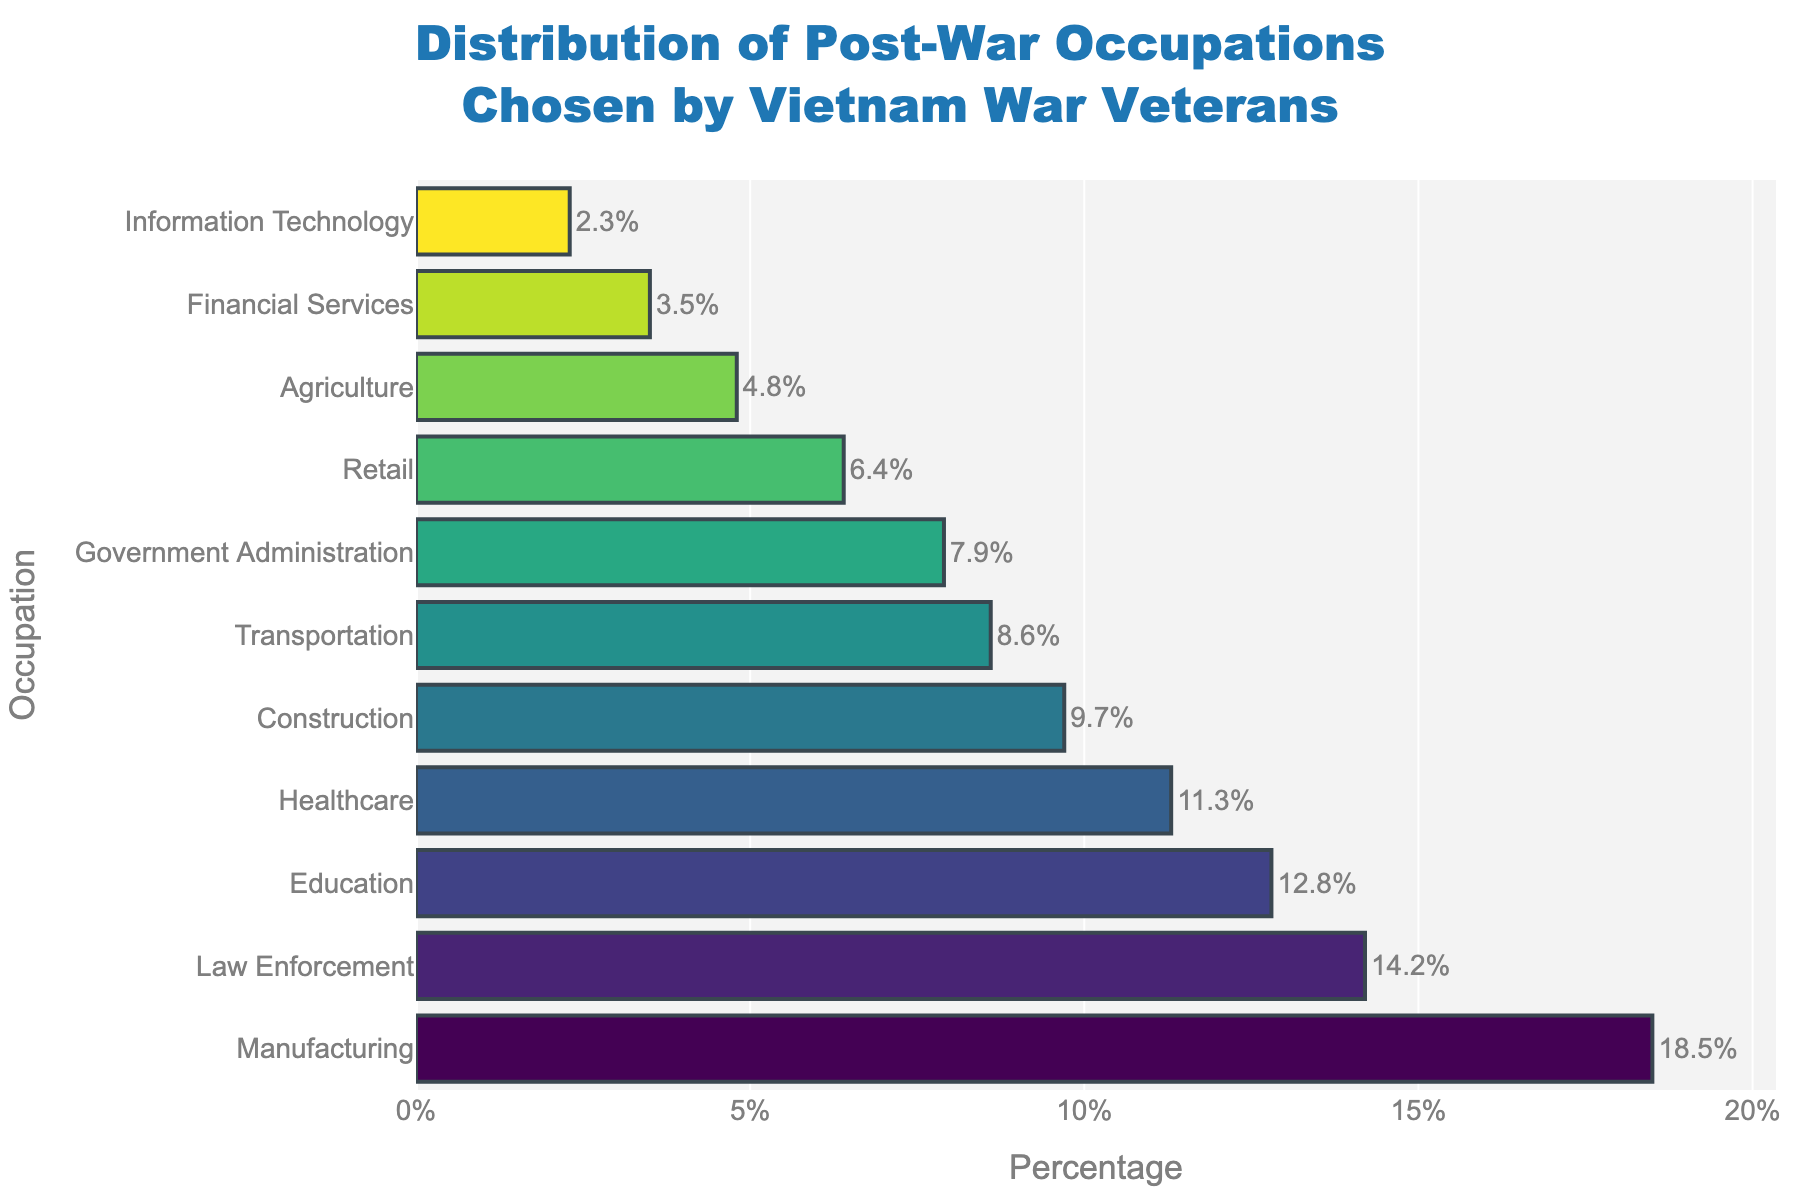What's the most common post-war occupation chosen by Vietnam War veterans? Look for the occupation with the highest percentage on the bar chart, which is Manufacturing with 18.5%.
Answer: Manufacturing Which post-war occupation has the lowest percentage? Identify the occupation with the shortest bar, which corresponds to Information Technology with 2.3%.
Answer: Information Technology What is the difference in percentage between the top two post-war occupations? Subtract the second highest percentage (Law Enforcement, 14.2%) from the highest percentage (Manufacturing, 18.5%). 18.5 - 14.2 = 4.3%.
Answer: 4.3% How much higher is the proportion of veterans in Manufacturing compared to those in Healthcare? Subtract the percentage for Healthcare (11.3%) from that of Manufacturing (18.5%). 18.5 - 11.3 = 7.2%.
Answer: 7.2% What is the combined percentage of veterans in Education, Healthcare, and Construction? Sum the three percentages: Education (12.8%), Healthcare (11.3%), and Construction (9.7%). 12.8 + 11.3 + 9.7 = 33.8%.
Answer: 33.8% Are there more veterans in Transportation or in Government Administration? Compare the percentages: Transportation has 8.6% while Government Administration has 7.9%. 8.6 > 7.9.
Answer: Transportation Which occupation has a percentage closest to 10%? Find the occupation whose percentage is nearest to 10%. Construction at 9.7% is the closest.
Answer: Construction What percentage of veterans chose Financial Services, and how does it compare to Retail? Financial Services has 3.5% while Retail has 6.4%. Since 3.5 < 6.4, Retail is more chosen.
Answer: Financial Services: 3.5%, Less than Retail What is the average percentage of veterans in the three least chosen occupations? Calculate the average of the percentages for the three occupations with the smallest values: Information Technology (2.3%), Financial Services (3.5%), and Agriculture (4.8%). (2.3 + 3.5 + 4.8) / 3 = 3.53%.
Answer: 3.53% What are the total percentages of veterans in Manufacturing, Law Enforcement, and Education combined? Sum the percentages for Manufacturing (18.5%), Law Enforcement (14.2%), and Education (12.8%). 18.5 + 14.2 + 12.8 = 45.5%.
Answer: 45.5% 